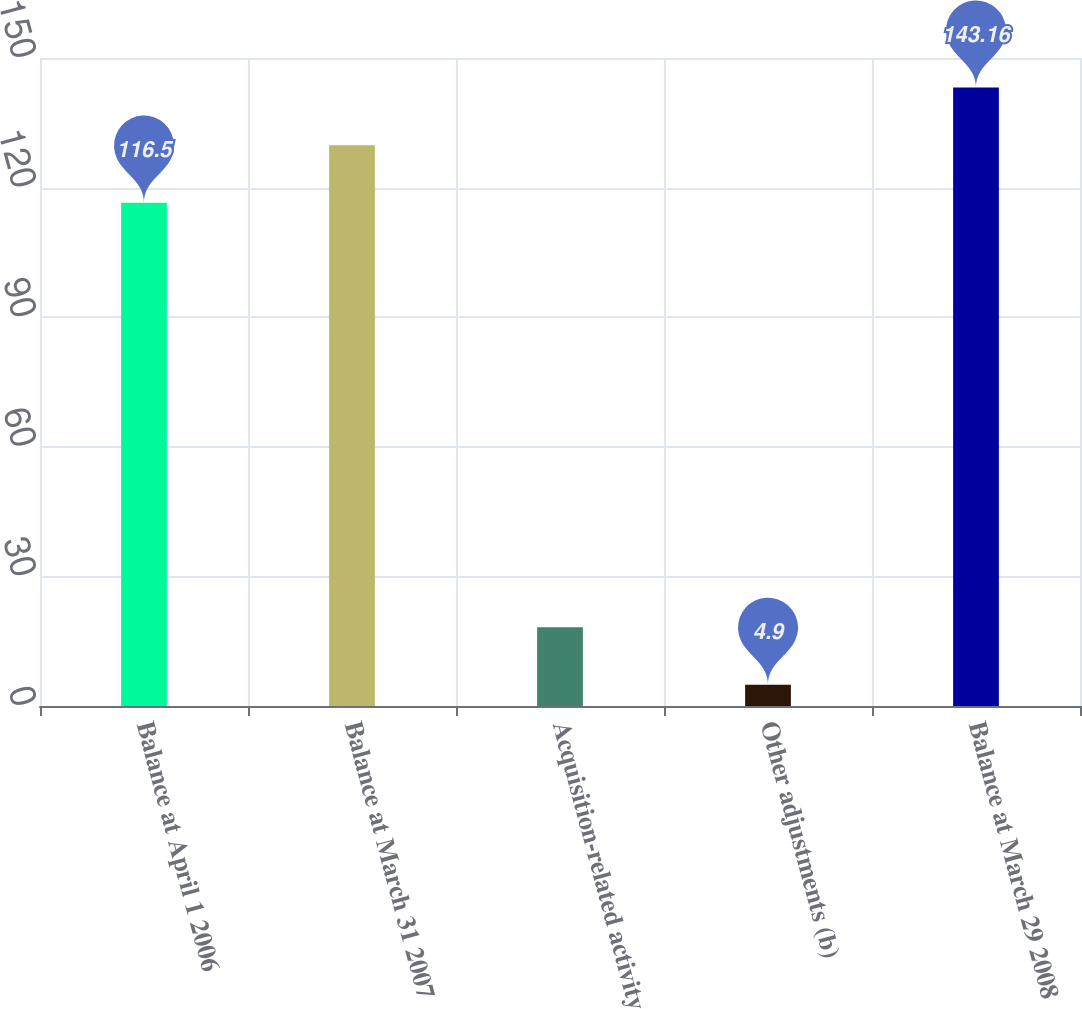Convert chart to OTSL. <chart><loc_0><loc_0><loc_500><loc_500><bar_chart><fcel>Balance at April 1 2006<fcel>Balance at March 31 2007<fcel>Acquisition-related activity<fcel>Other adjustments (b)<fcel>Balance at March 29 2008<nl><fcel>116.5<fcel>129.83<fcel>18.23<fcel>4.9<fcel>143.16<nl></chart> 